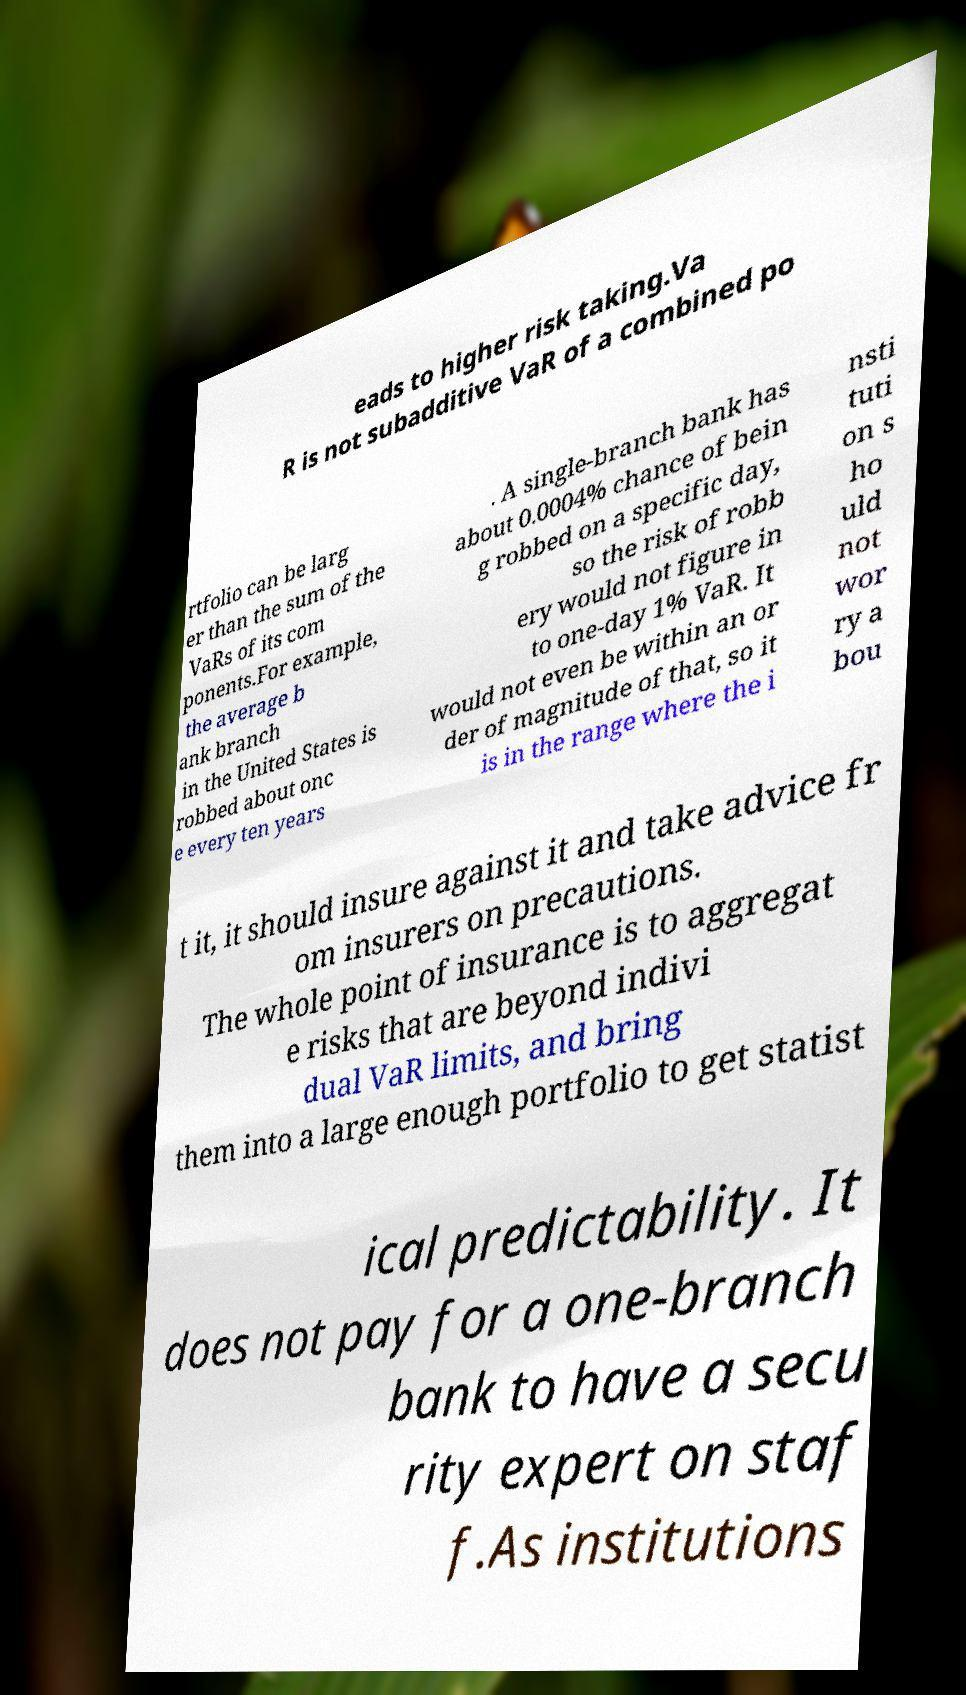Could you extract and type out the text from this image? eads to higher risk taking.Va R is not subadditive VaR of a combined po rtfolio can be larg er than the sum of the VaRs of its com ponents.For example, the average b ank branch in the United States is robbed about onc e every ten years . A single-branch bank has about 0.0004% chance of bein g robbed on a specific day, so the risk of robb ery would not figure in to one-day 1% VaR. It would not even be within an or der of magnitude of that, so it is in the range where the i nsti tuti on s ho uld not wor ry a bou t it, it should insure against it and take advice fr om insurers on precautions. The whole point of insurance is to aggregat e risks that are beyond indivi dual VaR limits, and bring them into a large enough portfolio to get statist ical predictability. It does not pay for a one-branch bank to have a secu rity expert on staf f.As institutions 